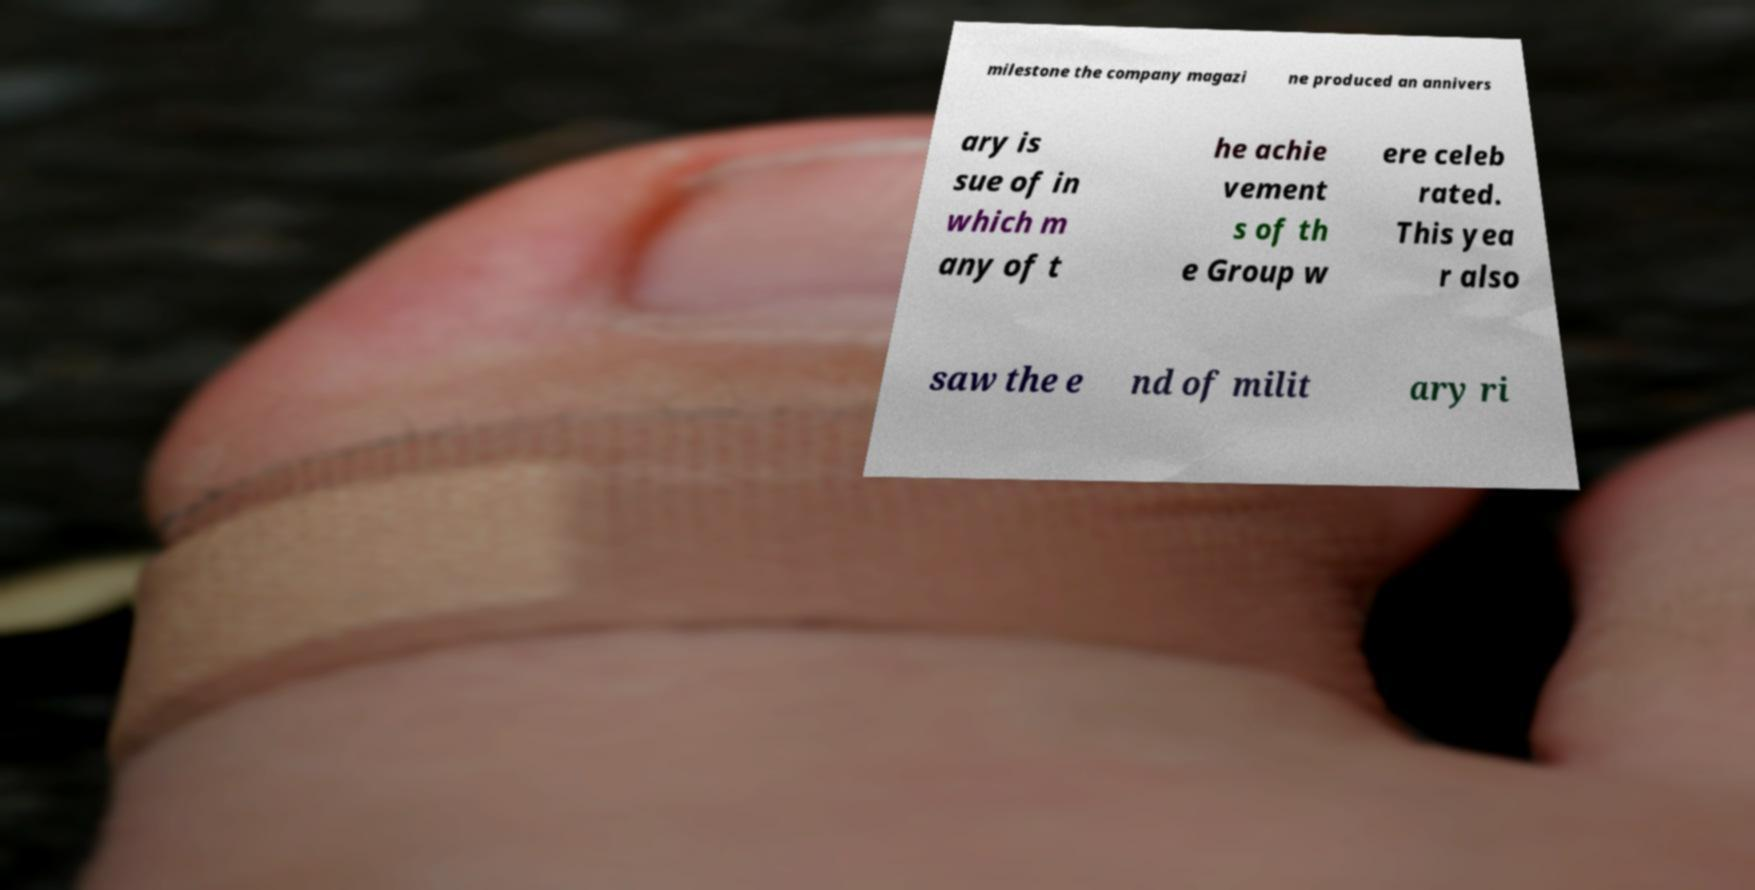I need the written content from this picture converted into text. Can you do that? milestone the company magazi ne produced an annivers ary is sue of in which m any of t he achie vement s of th e Group w ere celeb rated. This yea r also saw the e nd of milit ary ri 